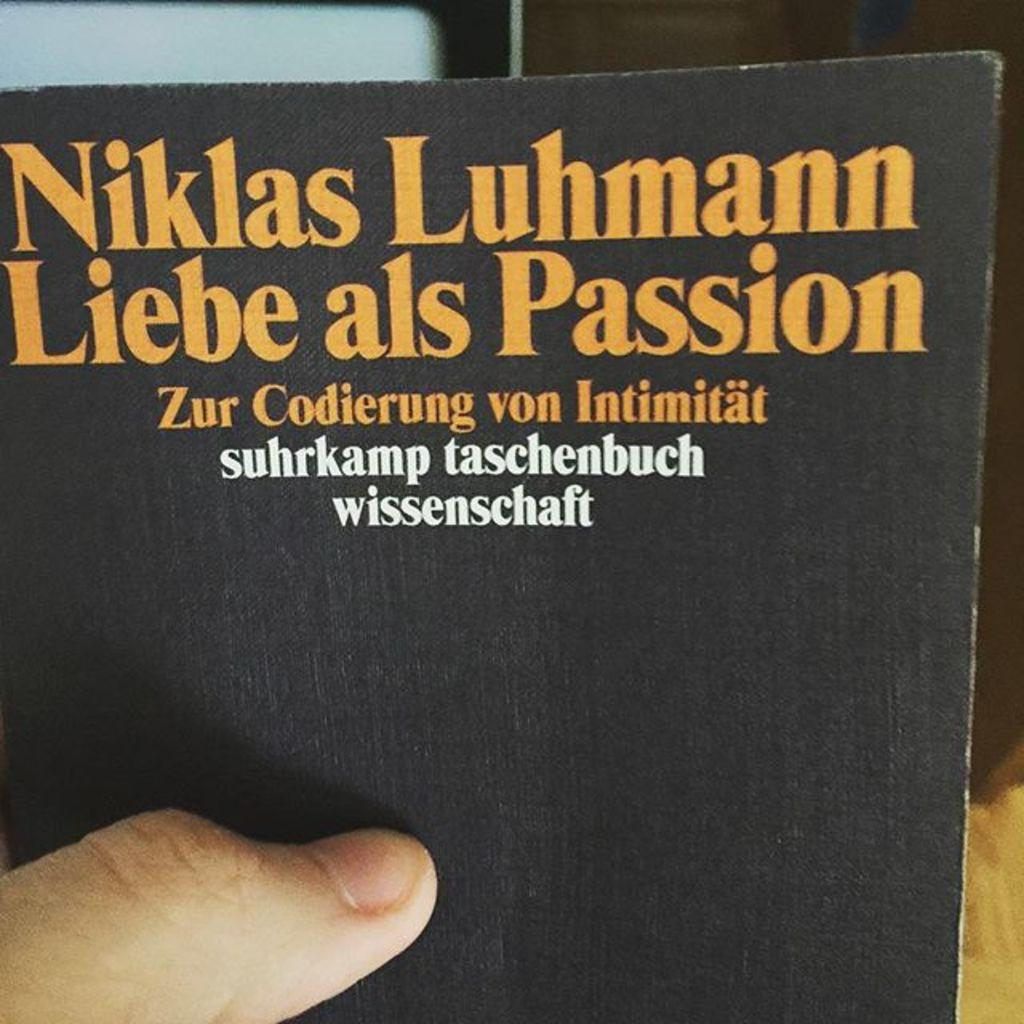Provide a one-sentence caption for the provided image. One thumb on the cover of this Niklas Luhmann book shows that a person is holding it up infront of the camera. 